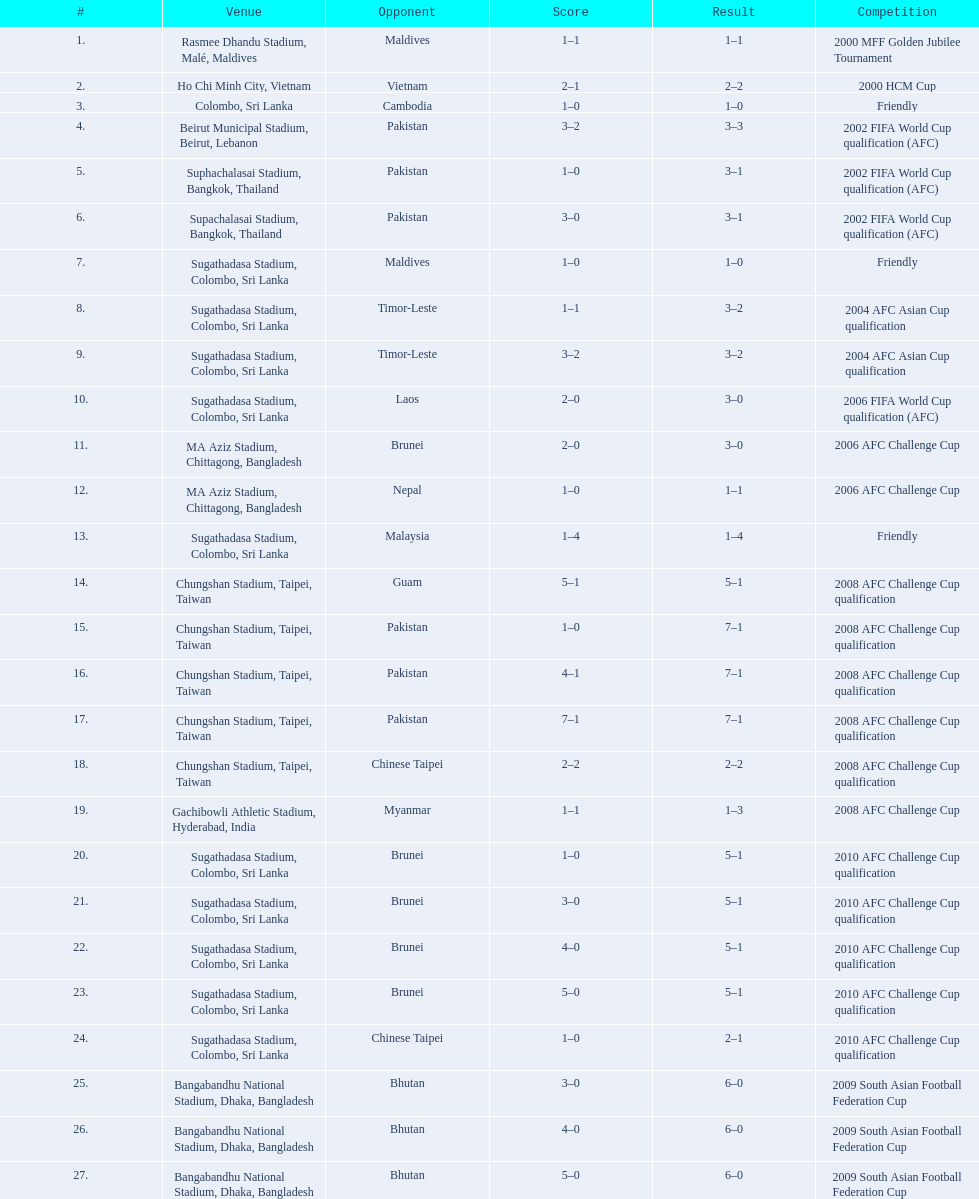What are the venues Rasmee Dhandu Stadium, Malé, Maldives, Ho Chi Minh City, Vietnam, Colombo, Sri Lanka, Beirut Municipal Stadium, Beirut, Lebanon, Suphachalasai Stadium, Bangkok, Thailand, Supachalasai Stadium, Bangkok, Thailand, Sugathadasa Stadium, Colombo, Sri Lanka, Sugathadasa Stadium, Colombo, Sri Lanka, Sugathadasa Stadium, Colombo, Sri Lanka, Sugathadasa Stadium, Colombo, Sri Lanka, MA Aziz Stadium, Chittagong, Bangladesh, MA Aziz Stadium, Chittagong, Bangladesh, Sugathadasa Stadium, Colombo, Sri Lanka, Chungshan Stadium, Taipei, Taiwan, Chungshan Stadium, Taipei, Taiwan, Chungshan Stadium, Taipei, Taiwan, Chungshan Stadium, Taipei, Taiwan, Chungshan Stadium, Taipei, Taiwan, Gachibowli Athletic Stadium, Hyderabad, India, Sugathadasa Stadium, Colombo, Sri Lanka, Sugathadasa Stadium, Colombo, Sri Lanka, Sugathadasa Stadium, Colombo, Sri Lanka, Sugathadasa Stadium, Colombo, Sri Lanka, Sugathadasa Stadium, Colombo, Sri Lanka, Bangabandhu National Stadium, Dhaka, Bangladesh, Bangabandhu National Stadium, Dhaka, Bangladesh, Bangabandhu National Stadium, Dhaka, Bangladesh. What are the #'s? 1., 2., 3., 4., 5., 6., 7., 8., 9., 10., 11., 12., 13., 14., 15., 16., 17., 18., 19., 20., 21., 22., 23., 24., 25., 26., 27. Which one is #1? Rasmee Dhandu Stadium, Malé, Maldives. 